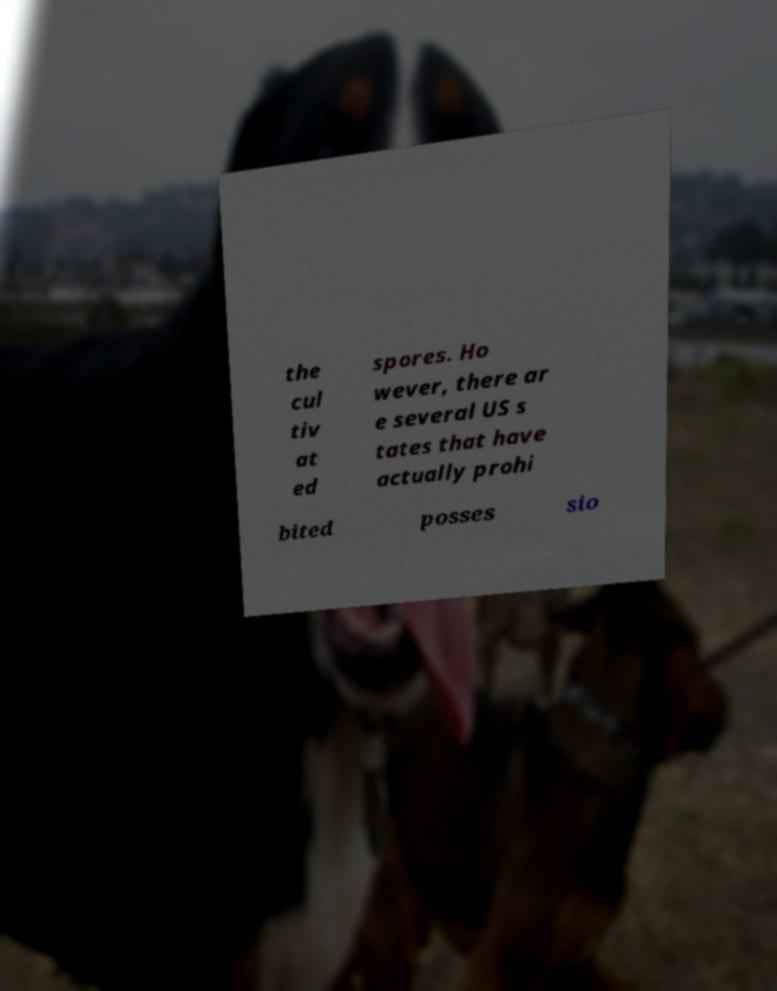For documentation purposes, I need the text within this image transcribed. Could you provide that? the cul tiv at ed spores. Ho wever, there ar e several US s tates that have actually prohi bited posses sio 